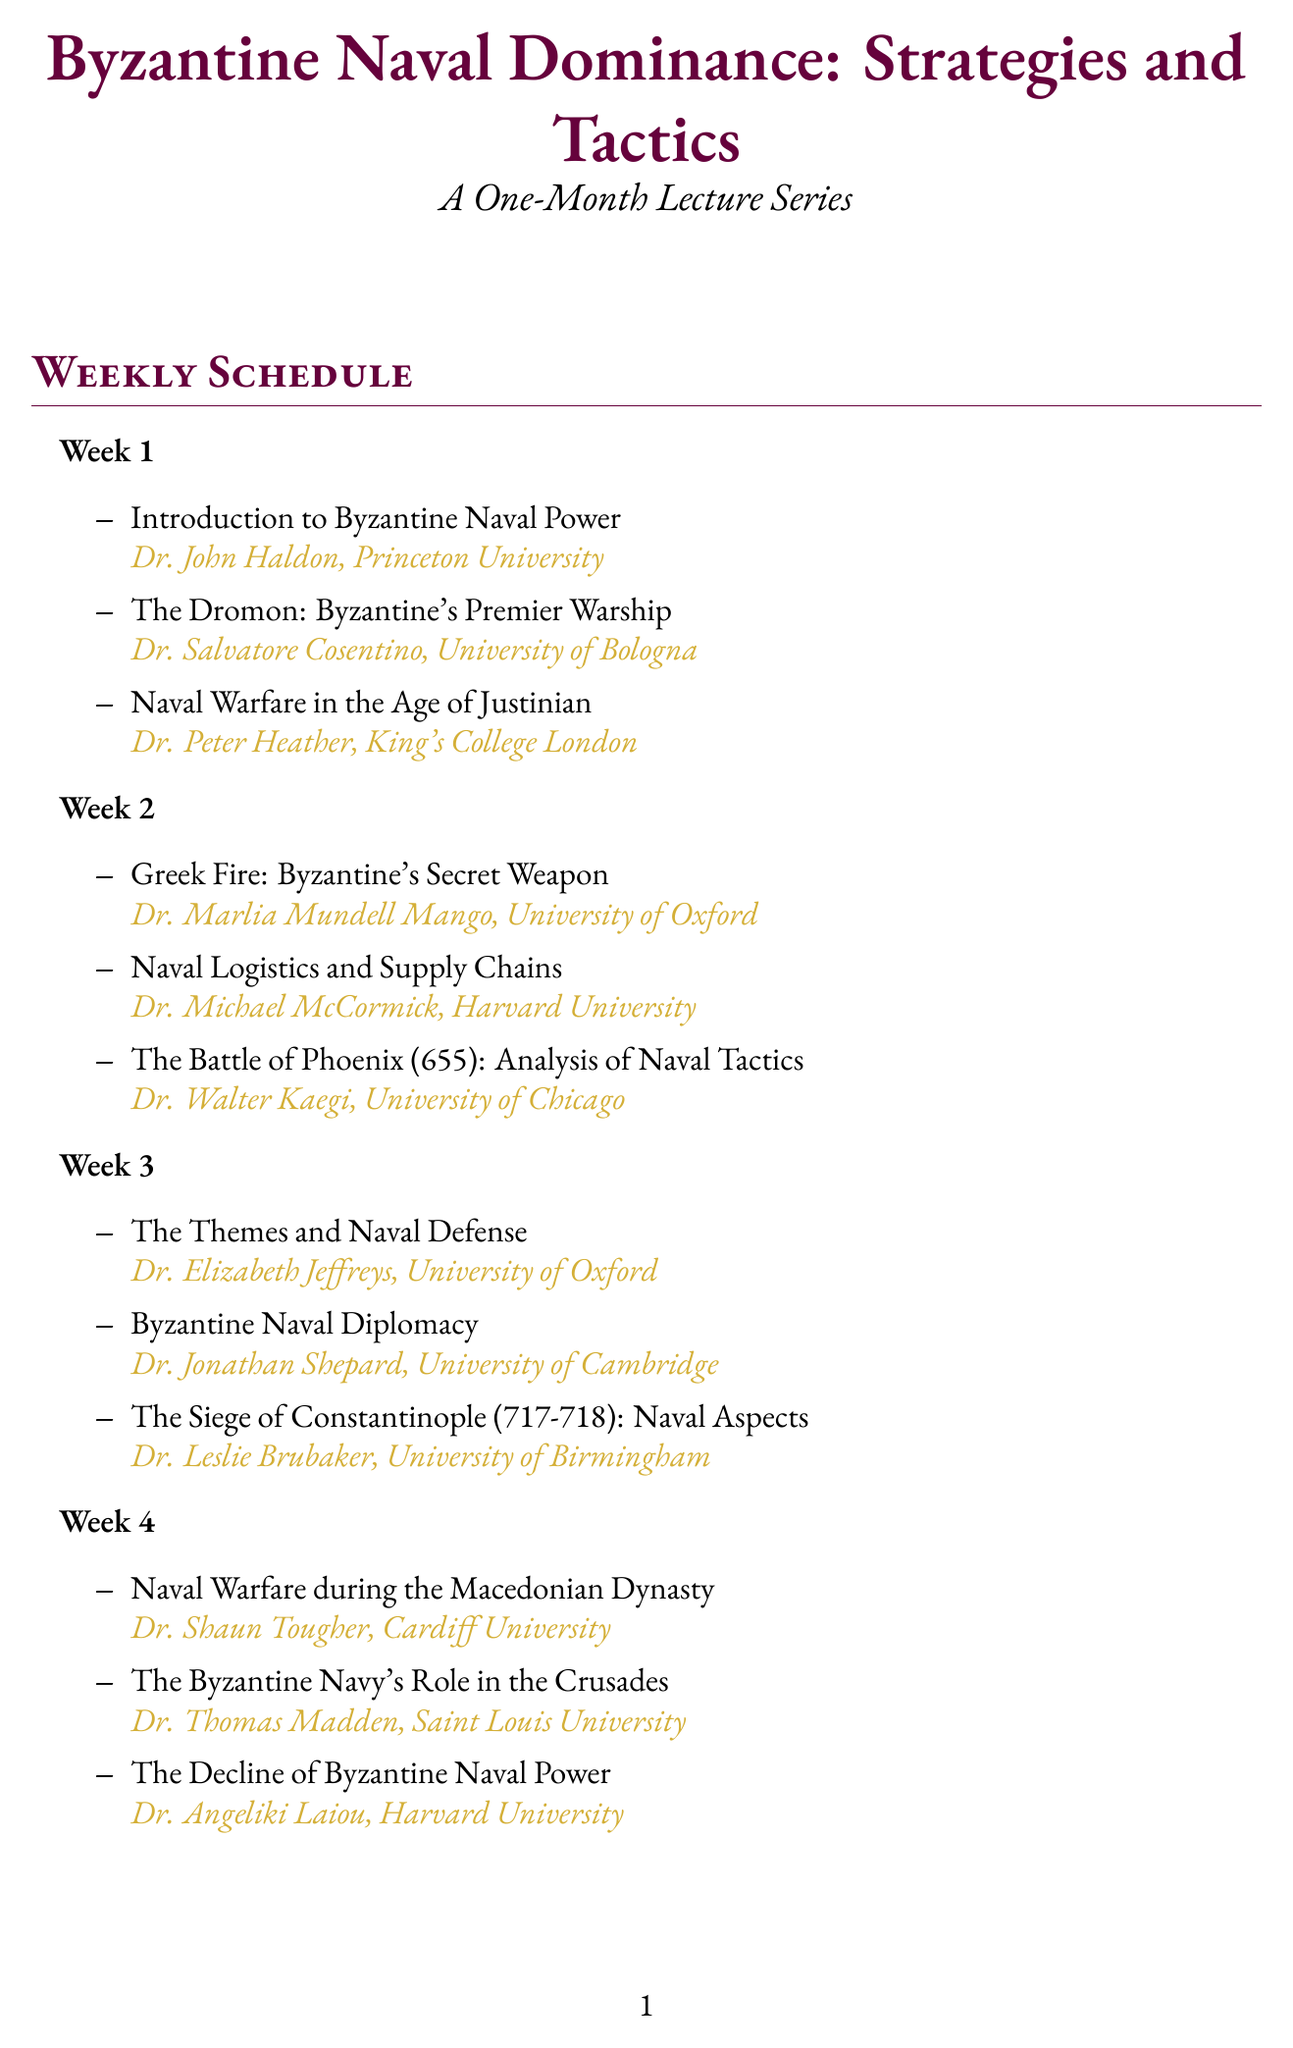What is the title of the lecture series? The title of the lecture series is provided in the document's header.
Answer: Byzantine Naval Dominance: Strategies and Tactics Who is the speaker for the first lecture of Week 1? The first lecture’s speaker is mentioned in the breakdown of Week 1’s topics.
Answer: Dr. John Haldon How many lectures are scheduled for Week 2? The document lists the number of topics under Week 2, which represent the lectures scheduled.
Answer: 3 What topic does Dr. Leslie Brubaker cover? Dr. Leslie Brubaker’s lecture is specified under the topics of Week 3.
Answer: The Siege of Constantinople (717-718): Naval Aspects Which university is Dr. Thomas Madden affiliated with? The speaker affiliations are included with each topic throughout the document.
Answer: Saint Louis University What week covers the topic 'Naval Warfare during the Macedonian Dynasty'? The topic's placement within the weeks is outlined in the document’s structure.
Answer: Week 4 What is one additional resource provided in the document? The document provides a list of additional resources related to the lecture series.
Answer: Virtual Tour of the Istanbul Naval Museum Identify one topic discussed in Week 2. The specific topics for Week 2 are listed in that section of the document.
Answer: Greek Fire: Byzantine's Secret Weapon Who analyzed the Battle of Phoenix (655)? The analysis of the Battle of Phoenix is associated with a specific speaker mentioned in that week.
Answer: Dr. Walter Kaegi 